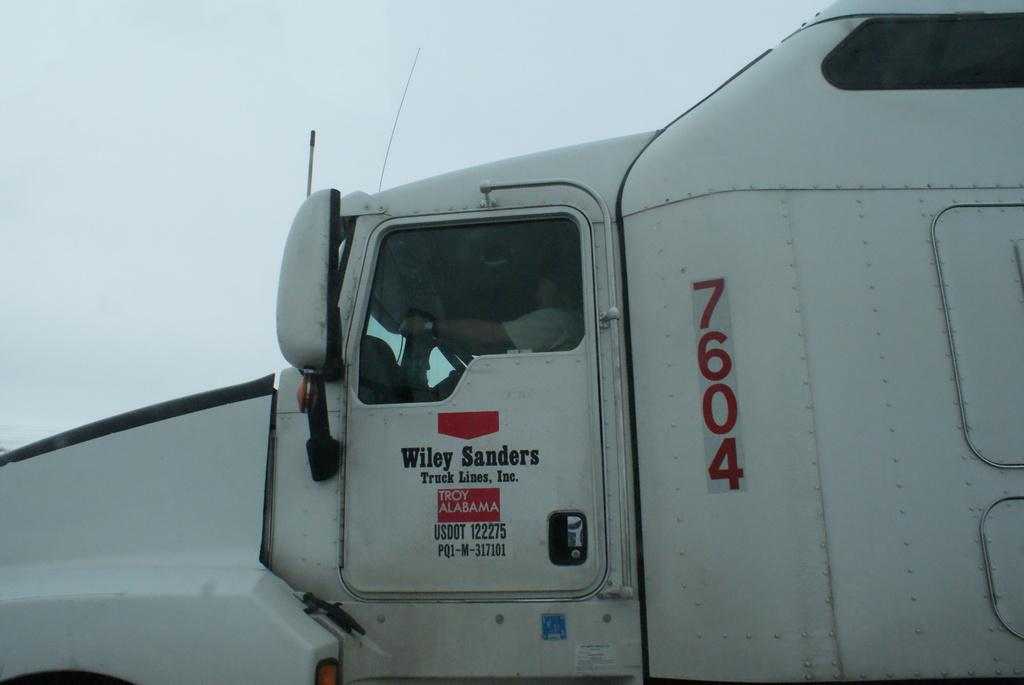What is the main subject of the image? There is a vehicle in the image. Can you describe the person inside the vehicle? A person is sitting inside the vehicle. What is written on the vehicle's door? There is text on the vehicle's door. What is visible at the top of the image? The sky is visible at the top of the image. What type of shoes is the cub wearing in the image? There is no cub or shoes present in the image. What scientific theory is being discussed in the image? There is no discussion of a scientific theory in the image. 